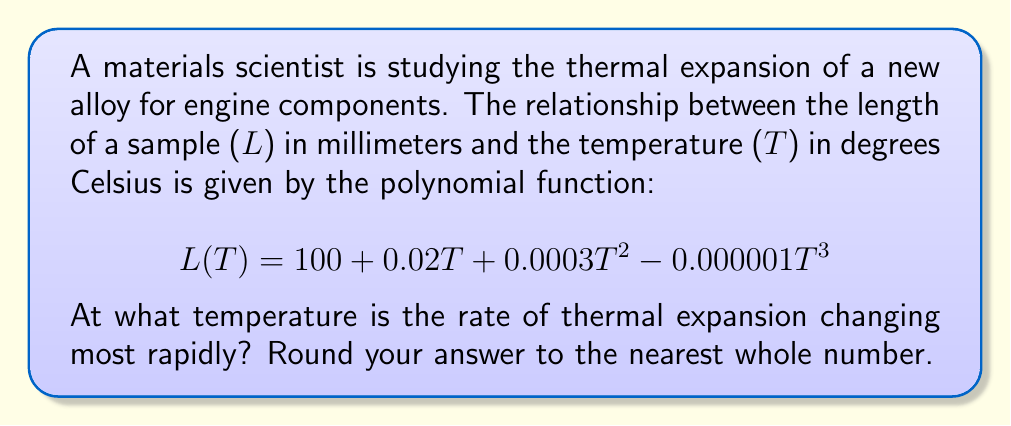Give your solution to this math problem. To find the temperature at which the rate of thermal expansion is changing most rapidly, we need to analyze the rate of change of the expansion rate. This involves finding the second derivative of the length function and determining where it reaches its maximum absolute value.

1. First, let's find the first derivative of L(T), which represents the rate of thermal expansion:

   $$L'(T) = 0.02 + 0.0006T - 0.000003T^2$$

2. Now, let's find the second derivative, which represents the rate of change of the expansion rate:

   $$L''(T) = 0.0006 - 0.000006T$$

3. To find where L''(T) reaches its maximum absolute value, we need to find where it equals zero:

   $$0.0006 - 0.000006T = 0$$
   $$0.0006 = 0.000006T$$
   $$T = 100$$

4. To confirm this is a maximum absolute value, we can check the values on either side:

   At T = 99: L''(99) = 0.0006 - 0.000006(99) = 0.000006
   At T = 101: L''(101) = 0.0006 - 0.000006(101) = -0.000006

   The sign changes from positive to negative, confirming a maximum absolute value at T = 100.

5. Therefore, the rate of thermal expansion is changing most rapidly at T = 100°C.
Answer: 100°C 